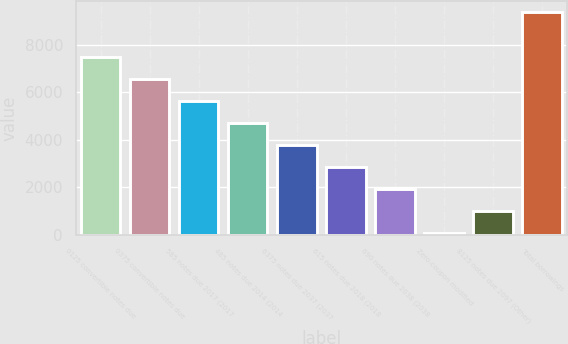Convert chart. <chart><loc_0><loc_0><loc_500><loc_500><bar_chart><fcel>0125 convertible notes due<fcel>0375 convertible notes due<fcel>585 notes due 2017 (2017<fcel>485 notes due 2014 (2014<fcel>6375 notes due 2037 (2037<fcel>615 notes due 2018 (2018<fcel>690 notes due 2038 (2038<fcel>Zero-coupon modified<fcel>8125 notes due 2097 (Other)<fcel>Total borrowings<nl><fcel>7497.8<fcel>6570.7<fcel>5643.6<fcel>4716.5<fcel>3789.4<fcel>2862.3<fcel>1935.2<fcel>81<fcel>1008.1<fcel>9352<nl></chart> 